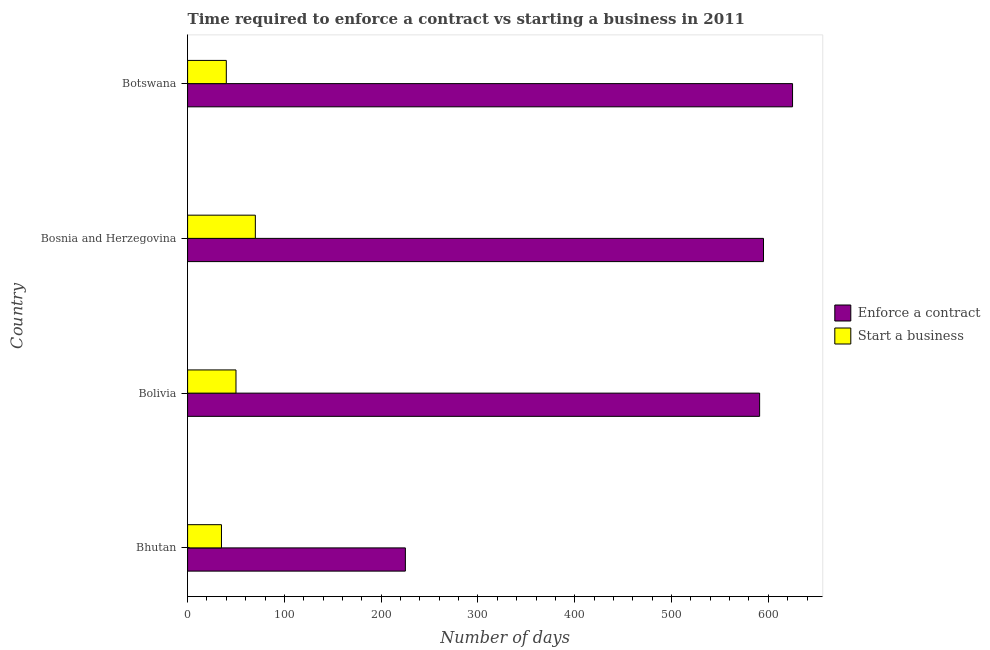How many different coloured bars are there?
Your answer should be compact. 2. Are the number of bars per tick equal to the number of legend labels?
Give a very brief answer. Yes. Are the number of bars on each tick of the Y-axis equal?
Your answer should be compact. Yes. How many bars are there on the 3rd tick from the bottom?
Keep it short and to the point. 2. What is the label of the 1st group of bars from the top?
Provide a succinct answer. Botswana. In how many cases, is the number of bars for a given country not equal to the number of legend labels?
Offer a terse response. 0. Across all countries, what is the maximum number of days to start a business?
Your answer should be compact. 70. Across all countries, what is the minimum number of days to start a business?
Give a very brief answer. 35. In which country was the number of days to enforece a contract maximum?
Offer a terse response. Botswana. In which country was the number of days to enforece a contract minimum?
Ensure brevity in your answer.  Bhutan. What is the total number of days to start a business in the graph?
Offer a very short reply. 195. What is the difference between the number of days to start a business in Bhutan and that in Bolivia?
Offer a very short reply. -15. What is the difference between the number of days to enforece a contract in Bosnia and Herzegovina and the number of days to start a business in Bolivia?
Make the answer very short. 545. What is the average number of days to start a business per country?
Your answer should be compact. 48.75. What is the difference between the number of days to enforece a contract and number of days to start a business in Botswana?
Ensure brevity in your answer.  585. In how many countries, is the number of days to start a business greater than 620 days?
Ensure brevity in your answer.  0. Is the difference between the number of days to start a business in Bolivia and Botswana greater than the difference between the number of days to enforece a contract in Bolivia and Botswana?
Provide a succinct answer. Yes. What is the difference between the highest and the second highest number of days to enforece a contract?
Make the answer very short. 30. What is the difference between the highest and the lowest number of days to enforece a contract?
Make the answer very short. 400. Is the sum of the number of days to start a business in Bolivia and Bosnia and Herzegovina greater than the maximum number of days to enforece a contract across all countries?
Ensure brevity in your answer.  No. What does the 2nd bar from the top in Bosnia and Herzegovina represents?
Make the answer very short. Enforce a contract. What does the 2nd bar from the bottom in Botswana represents?
Offer a terse response. Start a business. How many bars are there?
Keep it short and to the point. 8. Are all the bars in the graph horizontal?
Offer a very short reply. Yes. Does the graph contain any zero values?
Your response must be concise. No. Where does the legend appear in the graph?
Keep it short and to the point. Center right. How many legend labels are there?
Make the answer very short. 2. How are the legend labels stacked?
Provide a short and direct response. Vertical. What is the title of the graph?
Give a very brief answer. Time required to enforce a contract vs starting a business in 2011. What is the label or title of the X-axis?
Keep it short and to the point. Number of days. What is the label or title of the Y-axis?
Your answer should be very brief. Country. What is the Number of days of Enforce a contract in Bhutan?
Ensure brevity in your answer.  225. What is the Number of days of Start a business in Bhutan?
Provide a short and direct response. 35. What is the Number of days of Enforce a contract in Bolivia?
Give a very brief answer. 591. What is the Number of days of Enforce a contract in Bosnia and Herzegovina?
Ensure brevity in your answer.  595. What is the Number of days in Start a business in Bosnia and Herzegovina?
Ensure brevity in your answer.  70. What is the Number of days of Enforce a contract in Botswana?
Offer a very short reply. 625. What is the Number of days in Start a business in Botswana?
Your answer should be very brief. 40. Across all countries, what is the maximum Number of days of Enforce a contract?
Give a very brief answer. 625. Across all countries, what is the maximum Number of days in Start a business?
Your answer should be compact. 70. Across all countries, what is the minimum Number of days in Enforce a contract?
Keep it short and to the point. 225. Across all countries, what is the minimum Number of days of Start a business?
Your answer should be compact. 35. What is the total Number of days in Enforce a contract in the graph?
Your answer should be compact. 2036. What is the total Number of days of Start a business in the graph?
Give a very brief answer. 195. What is the difference between the Number of days in Enforce a contract in Bhutan and that in Bolivia?
Ensure brevity in your answer.  -366. What is the difference between the Number of days in Enforce a contract in Bhutan and that in Bosnia and Herzegovina?
Offer a terse response. -370. What is the difference between the Number of days of Start a business in Bhutan and that in Bosnia and Herzegovina?
Offer a terse response. -35. What is the difference between the Number of days in Enforce a contract in Bhutan and that in Botswana?
Ensure brevity in your answer.  -400. What is the difference between the Number of days in Start a business in Bhutan and that in Botswana?
Your response must be concise. -5. What is the difference between the Number of days of Enforce a contract in Bolivia and that in Bosnia and Herzegovina?
Your response must be concise. -4. What is the difference between the Number of days of Enforce a contract in Bolivia and that in Botswana?
Provide a succinct answer. -34. What is the difference between the Number of days of Start a business in Bolivia and that in Botswana?
Your response must be concise. 10. What is the difference between the Number of days in Enforce a contract in Bhutan and the Number of days in Start a business in Bolivia?
Provide a succinct answer. 175. What is the difference between the Number of days in Enforce a contract in Bhutan and the Number of days in Start a business in Bosnia and Herzegovina?
Your answer should be very brief. 155. What is the difference between the Number of days of Enforce a contract in Bhutan and the Number of days of Start a business in Botswana?
Give a very brief answer. 185. What is the difference between the Number of days in Enforce a contract in Bolivia and the Number of days in Start a business in Bosnia and Herzegovina?
Keep it short and to the point. 521. What is the difference between the Number of days in Enforce a contract in Bolivia and the Number of days in Start a business in Botswana?
Your answer should be very brief. 551. What is the difference between the Number of days in Enforce a contract in Bosnia and Herzegovina and the Number of days in Start a business in Botswana?
Your response must be concise. 555. What is the average Number of days in Enforce a contract per country?
Ensure brevity in your answer.  509. What is the average Number of days of Start a business per country?
Ensure brevity in your answer.  48.75. What is the difference between the Number of days of Enforce a contract and Number of days of Start a business in Bhutan?
Ensure brevity in your answer.  190. What is the difference between the Number of days of Enforce a contract and Number of days of Start a business in Bolivia?
Your response must be concise. 541. What is the difference between the Number of days of Enforce a contract and Number of days of Start a business in Bosnia and Herzegovina?
Provide a short and direct response. 525. What is the difference between the Number of days in Enforce a contract and Number of days in Start a business in Botswana?
Provide a succinct answer. 585. What is the ratio of the Number of days of Enforce a contract in Bhutan to that in Bolivia?
Your answer should be compact. 0.38. What is the ratio of the Number of days in Enforce a contract in Bhutan to that in Bosnia and Herzegovina?
Provide a succinct answer. 0.38. What is the ratio of the Number of days of Enforce a contract in Bhutan to that in Botswana?
Your answer should be compact. 0.36. What is the ratio of the Number of days of Enforce a contract in Bolivia to that in Botswana?
Offer a very short reply. 0.95. What is the ratio of the Number of days of Enforce a contract in Bosnia and Herzegovina to that in Botswana?
Provide a short and direct response. 0.95. What is the difference between the highest and the second highest Number of days in Start a business?
Provide a short and direct response. 20. What is the difference between the highest and the lowest Number of days in Enforce a contract?
Your response must be concise. 400. 